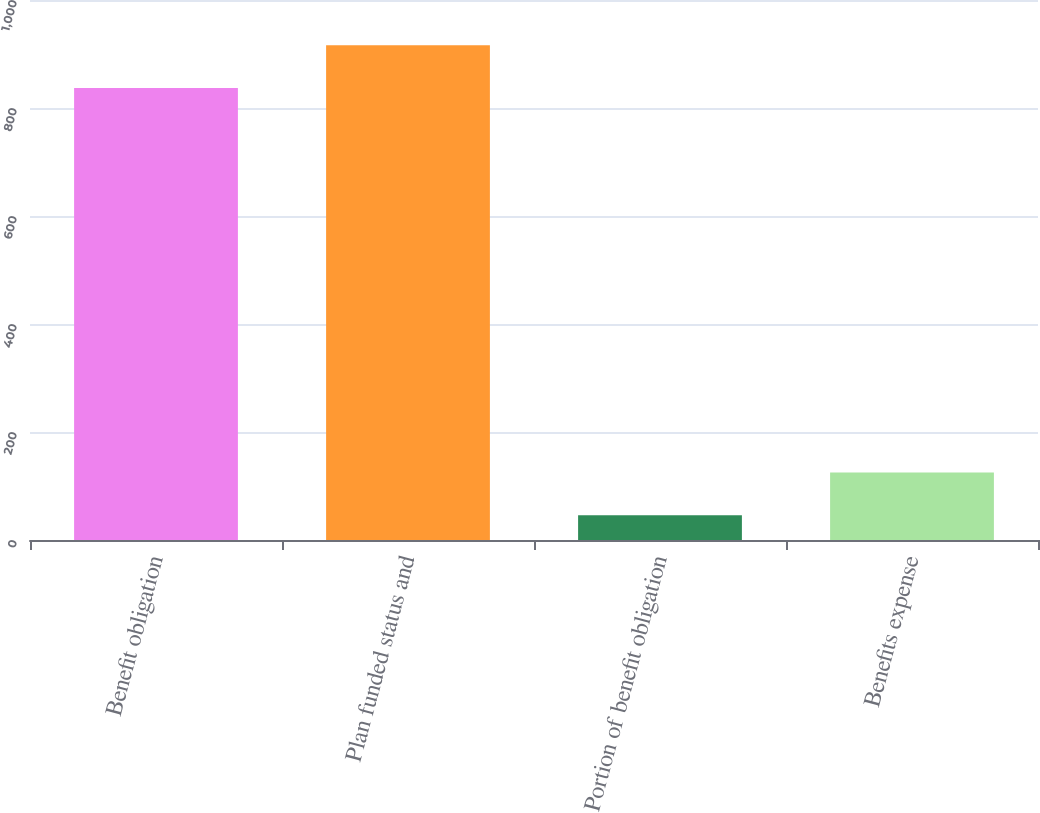Convert chart. <chart><loc_0><loc_0><loc_500><loc_500><bar_chart><fcel>Benefit obligation<fcel>Plan funded status and<fcel>Portion of benefit obligation<fcel>Benefits expense<nl><fcel>837<fcel>916.1<fcel>46<fcel>125.1<nl></chart> 